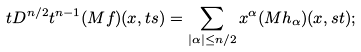Convert formula to latex. <formula><loc_0><loc_0><loc_500><loc_500>t D ^ { n / 2 } t ^ { n - 1 } ( M f ) ( x , t s ) & = \sum _ { | \alpha | \leq n / 2 } x ^ { \alpha } ( M h _ { \alpha } ) ( x , s t ) ;</formula> 